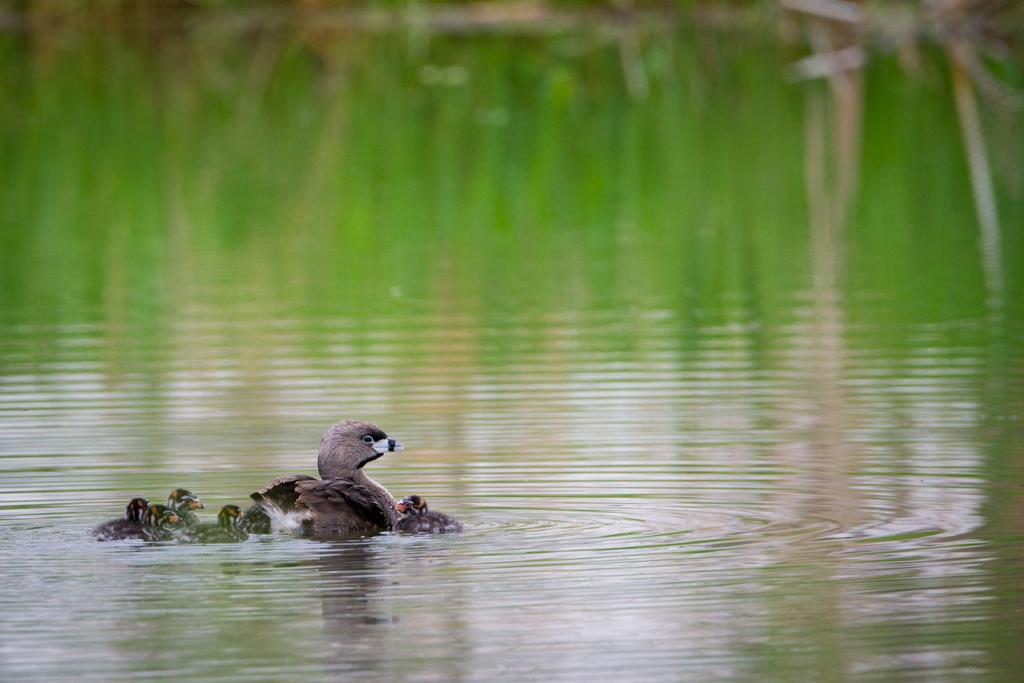What type of animals can be seen in the image? There are birds in the image. Where are the birds located in the image? The birds are on the water. What type of can is visible in the image? There is no can present in the image; it features birds on the water. Who is the representative of the birds in the image? There is no representative for the birds in the image, as they are simply depicted in their natural environment. 